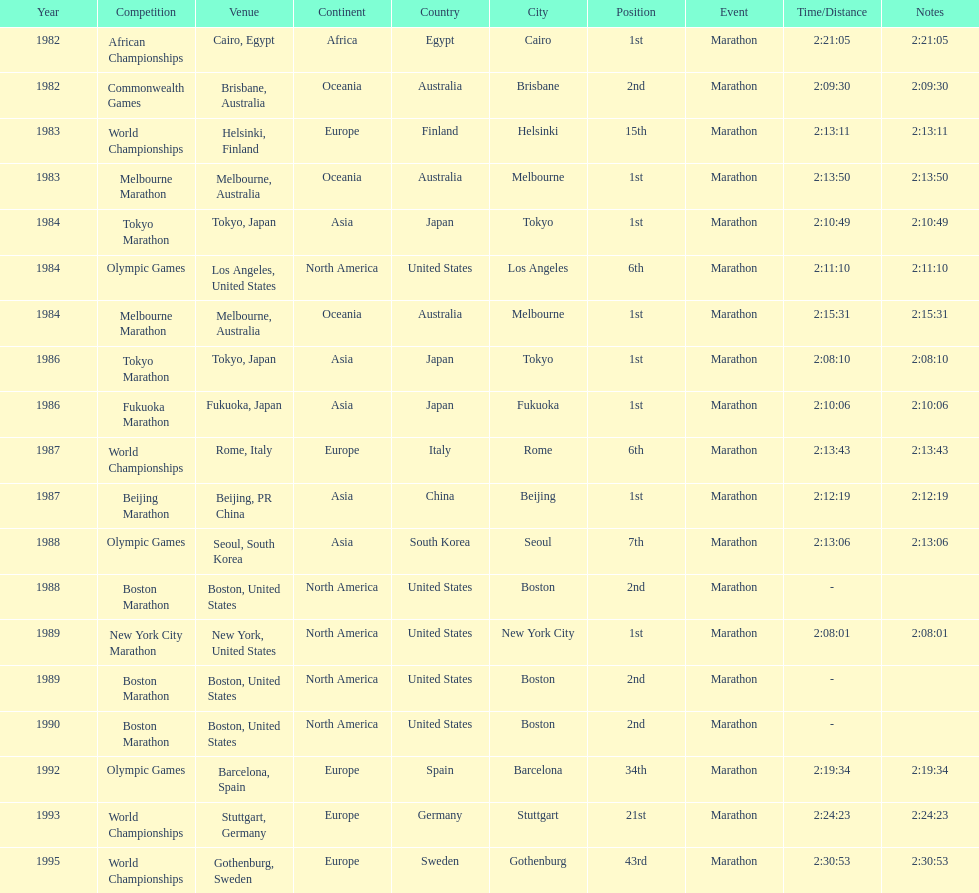What are the total number of times the position of 1st place was earned? 8. 